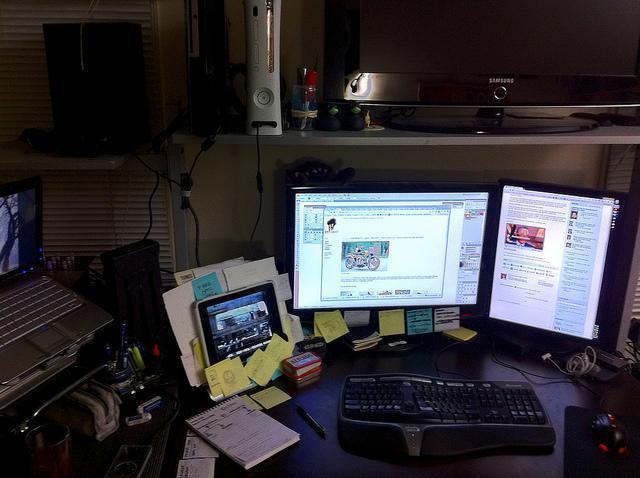What is the item called that has the red lights emanating from it?
Pick the correct solution from the four options below to address the question.
Options: Keyboard, notepad, flashlight, mouse. Mouse. 